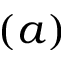Convert formula to latex. <formula><loc_0><loc_0><loc_500><loc_500>( a )</formula> 